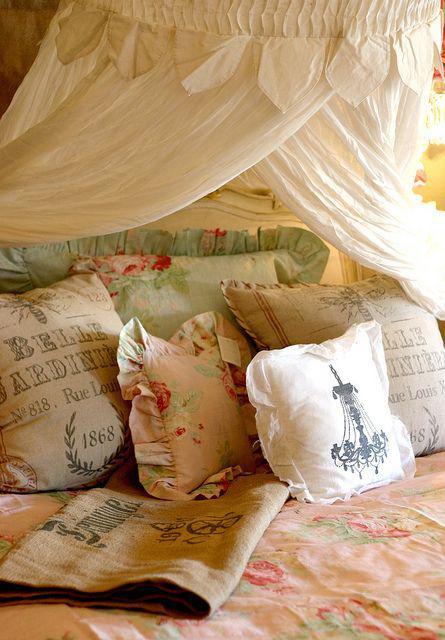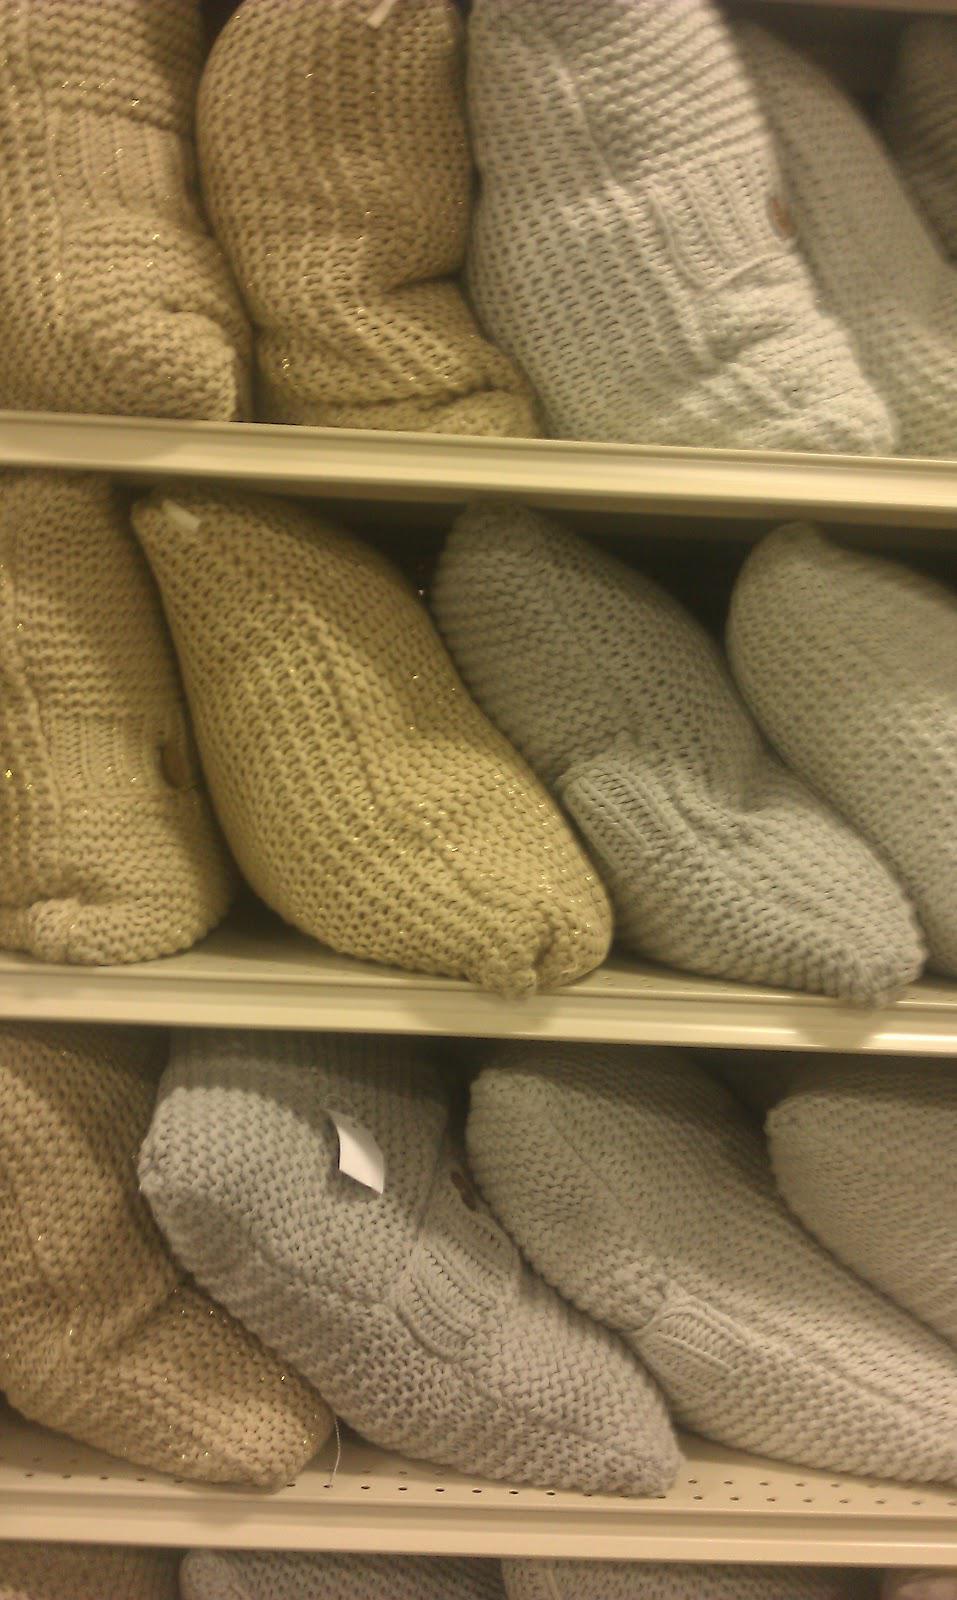The first image is the image on the left, the second image is the image on the right. For the images shown, is this caption "An image shows pillows on a bed with a deep brown headboard." true? Answer yes or no. No. 